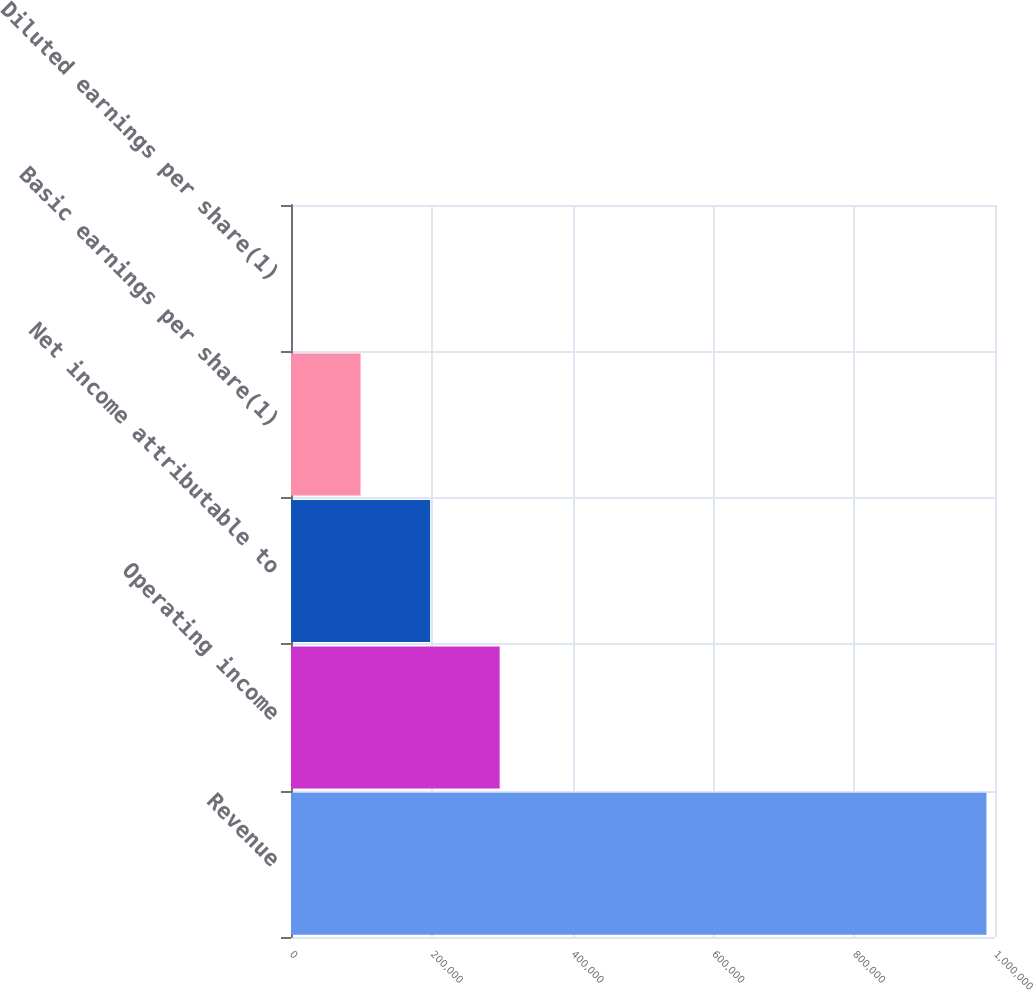<chart> <loc_0><loc_0><loc_500><loc_500><bar_chart><fcel>Revenue<fcel>Operating income<fcel>Net income attributable to<fcel>Basic earnings per share(1)<fcel>Diluted earnings per share(1)<nl><fcel>987860<fcel>296358<fcel>197572<fcel>98786.6<fcel>0.62<nl></chart> 